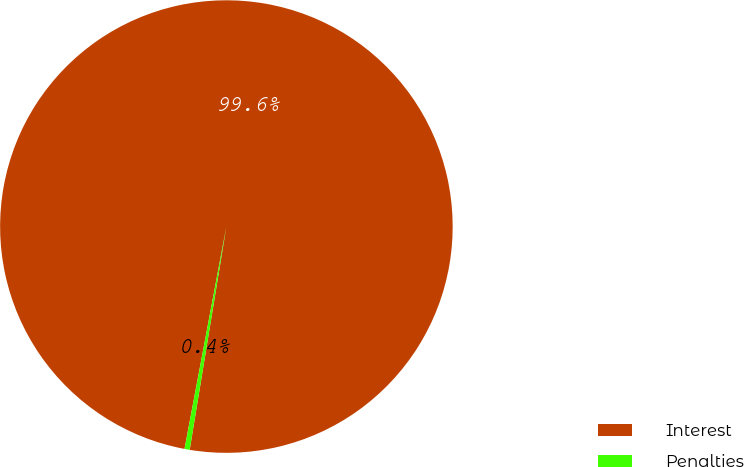Convert chart. <chart><loc_0><loc_0><loc_500><loc_500><pie_chart><fcel>Interest<fcel>Penalties<nl><fcel>99.63%<fcel>0.37%<nl></chart> 